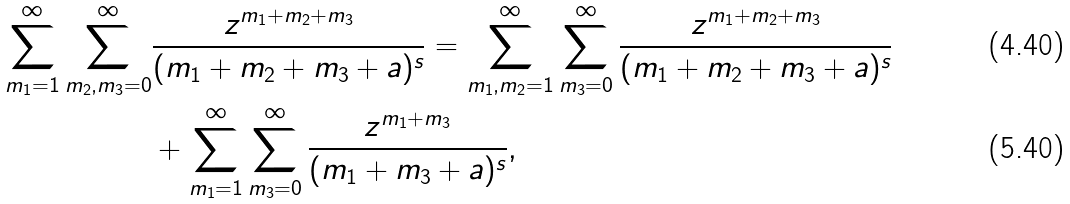Convert formula to latex. <formula><loc_0><loc_0><loc_500><loc_500>\sum _ { m _ { 1 } = 1 } ^ { \infty } \sum _ { m _ { 2 } , m _ { 3 } = 0 } ^ { \infty } & \frac { z ^ { m _ { 1 } + m _ { 2 } + m _ { 3 } } } { ( m _ { 1 } + m _ { 2 } + m _ { 3 } + a ) ^ { s } } = \sum _ { m _ { 1 } , m _ { 2 } = 1 } ^ { \infty } \sum _ { m _ { 3 } = 0 } ^ { \infty } \frac { z ^ { m _ { 1 } + m _ { 2 } + m _ { 3 } } } { ( m _ { 1 } + m _ { 2 } + m _ { 3 } + a ) ^ { s } } \\ & + \sum _ { m _ { 1 } = 1 } ^ { \infty } \sum _ { m _ { 3 } = 0 } ^ { \infty } \frac { z ^ { m _ { 1 } + m _ { 3 } } } { ( m _ { 1 } + m _ { 3 } + a ) ^ { s } } ,</formula> 